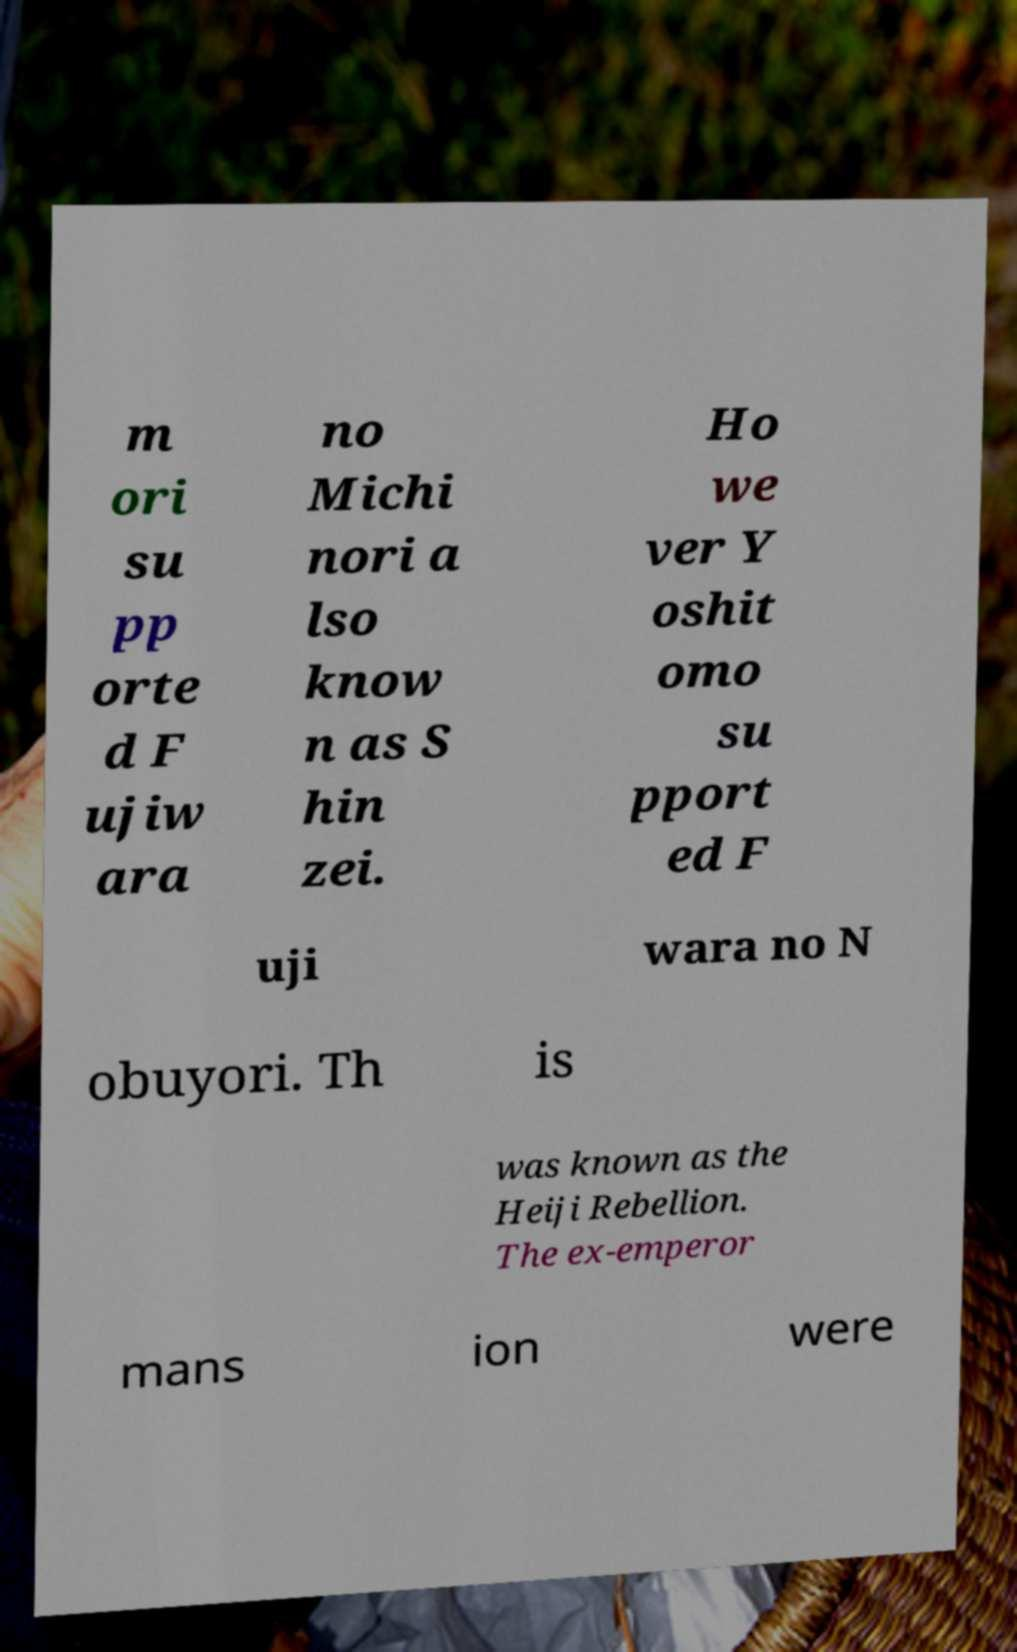Can you read and provide the text displayed in the image?This photo seems to have some interesting text. Can you extract and type it out for me? m ori su pp orte d F ujiw ara no Michi nori a lso know n as S hin zei. Ho we ver Y oshit omo su pport ed F uji wara no N obuyori. Th is was known as the Heiji Rebellion. The ex-emperor mans ion were 